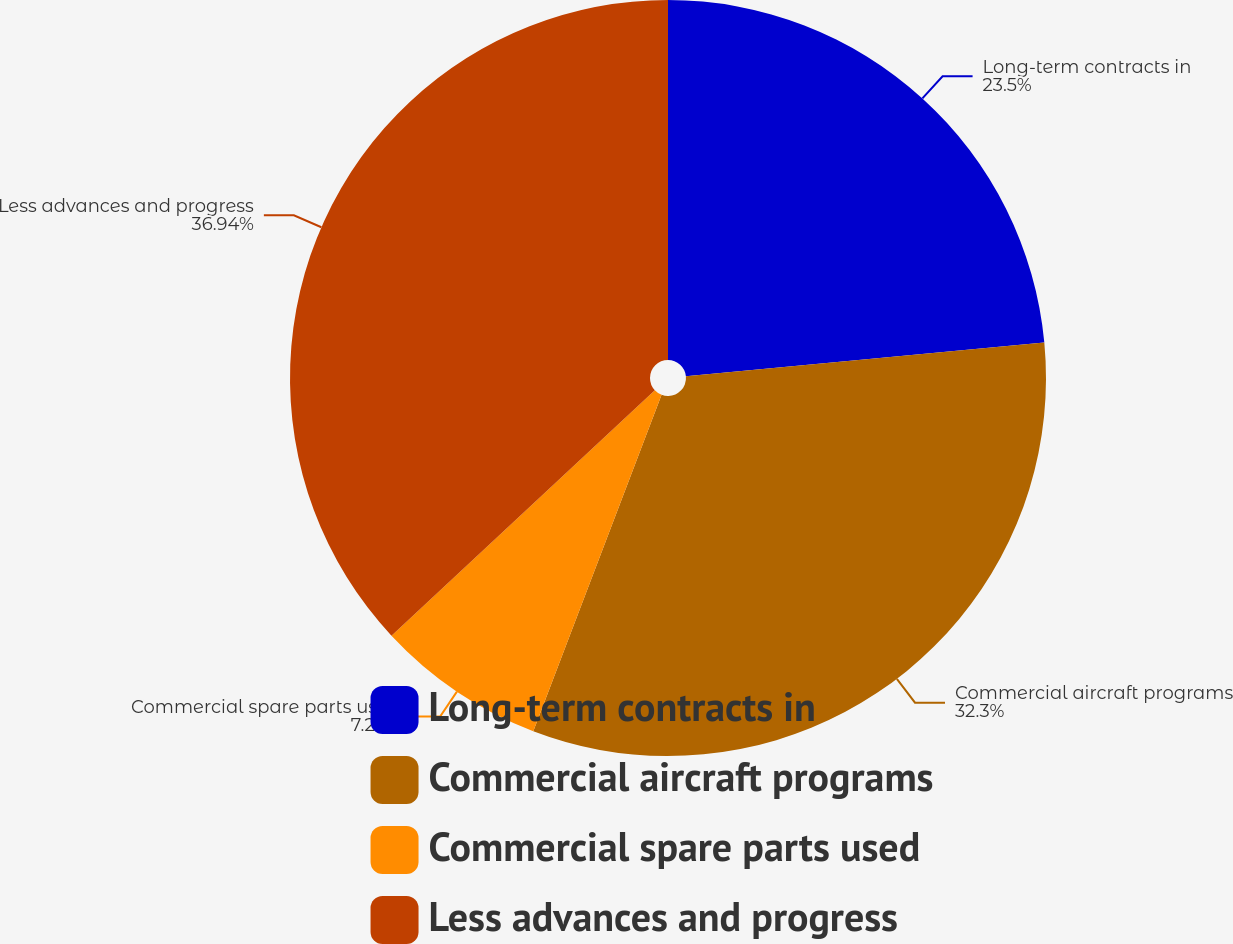Convert chart. <chart><loc_0><loc_0><loc_500><loc_500><pie_chart><fcel>Long-term contracts in<fcel>Commercial aircraft programs<fcel>Commercial spare parts used<fcel>Less advances and progress<nl><fcel>23.5%<fcel>32.3%<fcel>7.26%<fcel>36.94%<nl></chart> 